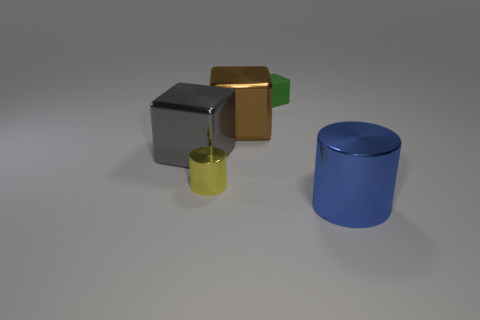There is a cube in front of the brown thing; how big is it? The cube appears to be medium-sized in comparison to the brown object behind it, with roughly equal dimensions in height, width, and depth. 